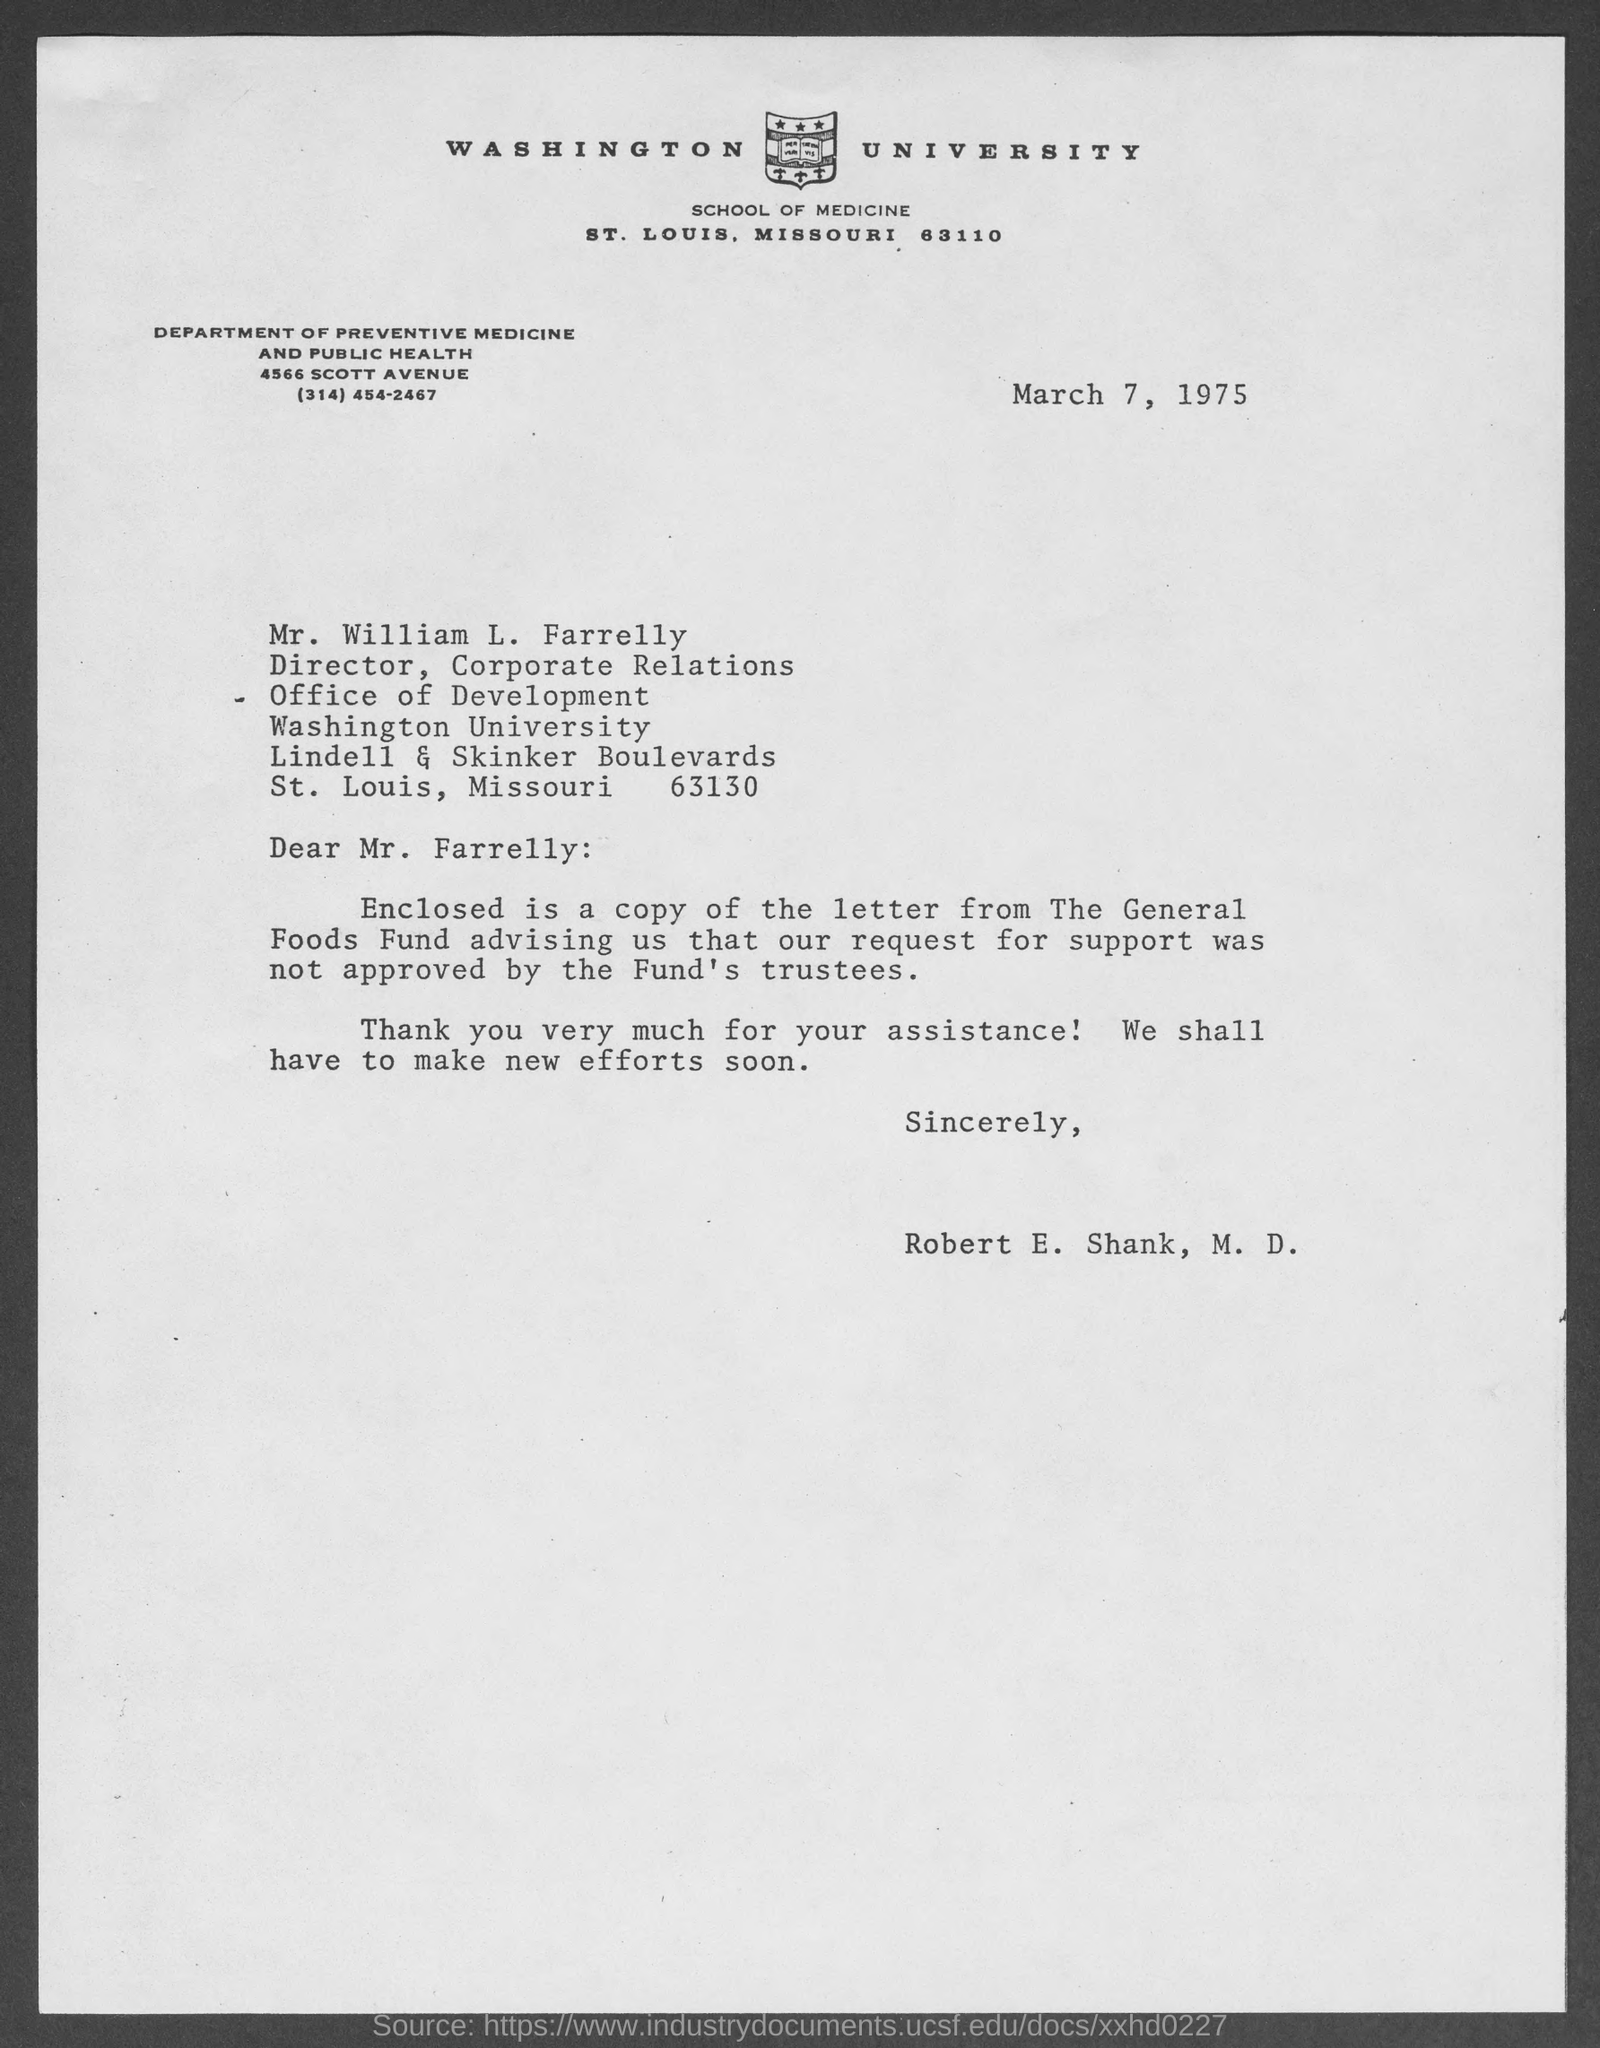Highlight a few significant elements in this photo. The General Foods Fund did not approve the request for support. The sender is Robert E. Shank. The document is dated March 7, 1975. The letter is addressed to Mr. William L. Farrelly. 